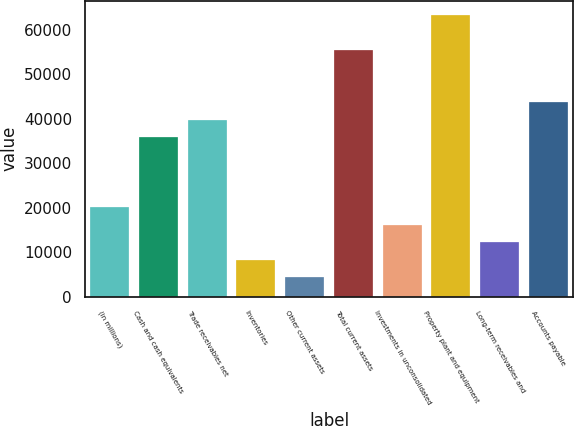Convert chart. <chart><loc_0><loc_0><loc_500><loc_500><bar_chart><fcel>(in millions)<fcel>Cash and cash equivalents<fcel>Trade receivables net<fcel>Inventories<fcel>Other current assets<fcel>Total current assets<fcel>Investments in unconsolidated<fcel>Property plant and equipment<fcel>Long-term receivables and<fcel>Accounts payable<nl><fcel>20072<fcel>35798.4<fcel>39730<fcel>8277.2<fcel>4345.6<fcel>55456.4<fcel>16140.4<fcel>63319.6<fcel>12208.8<fcel>43661.6<nl></chart> 